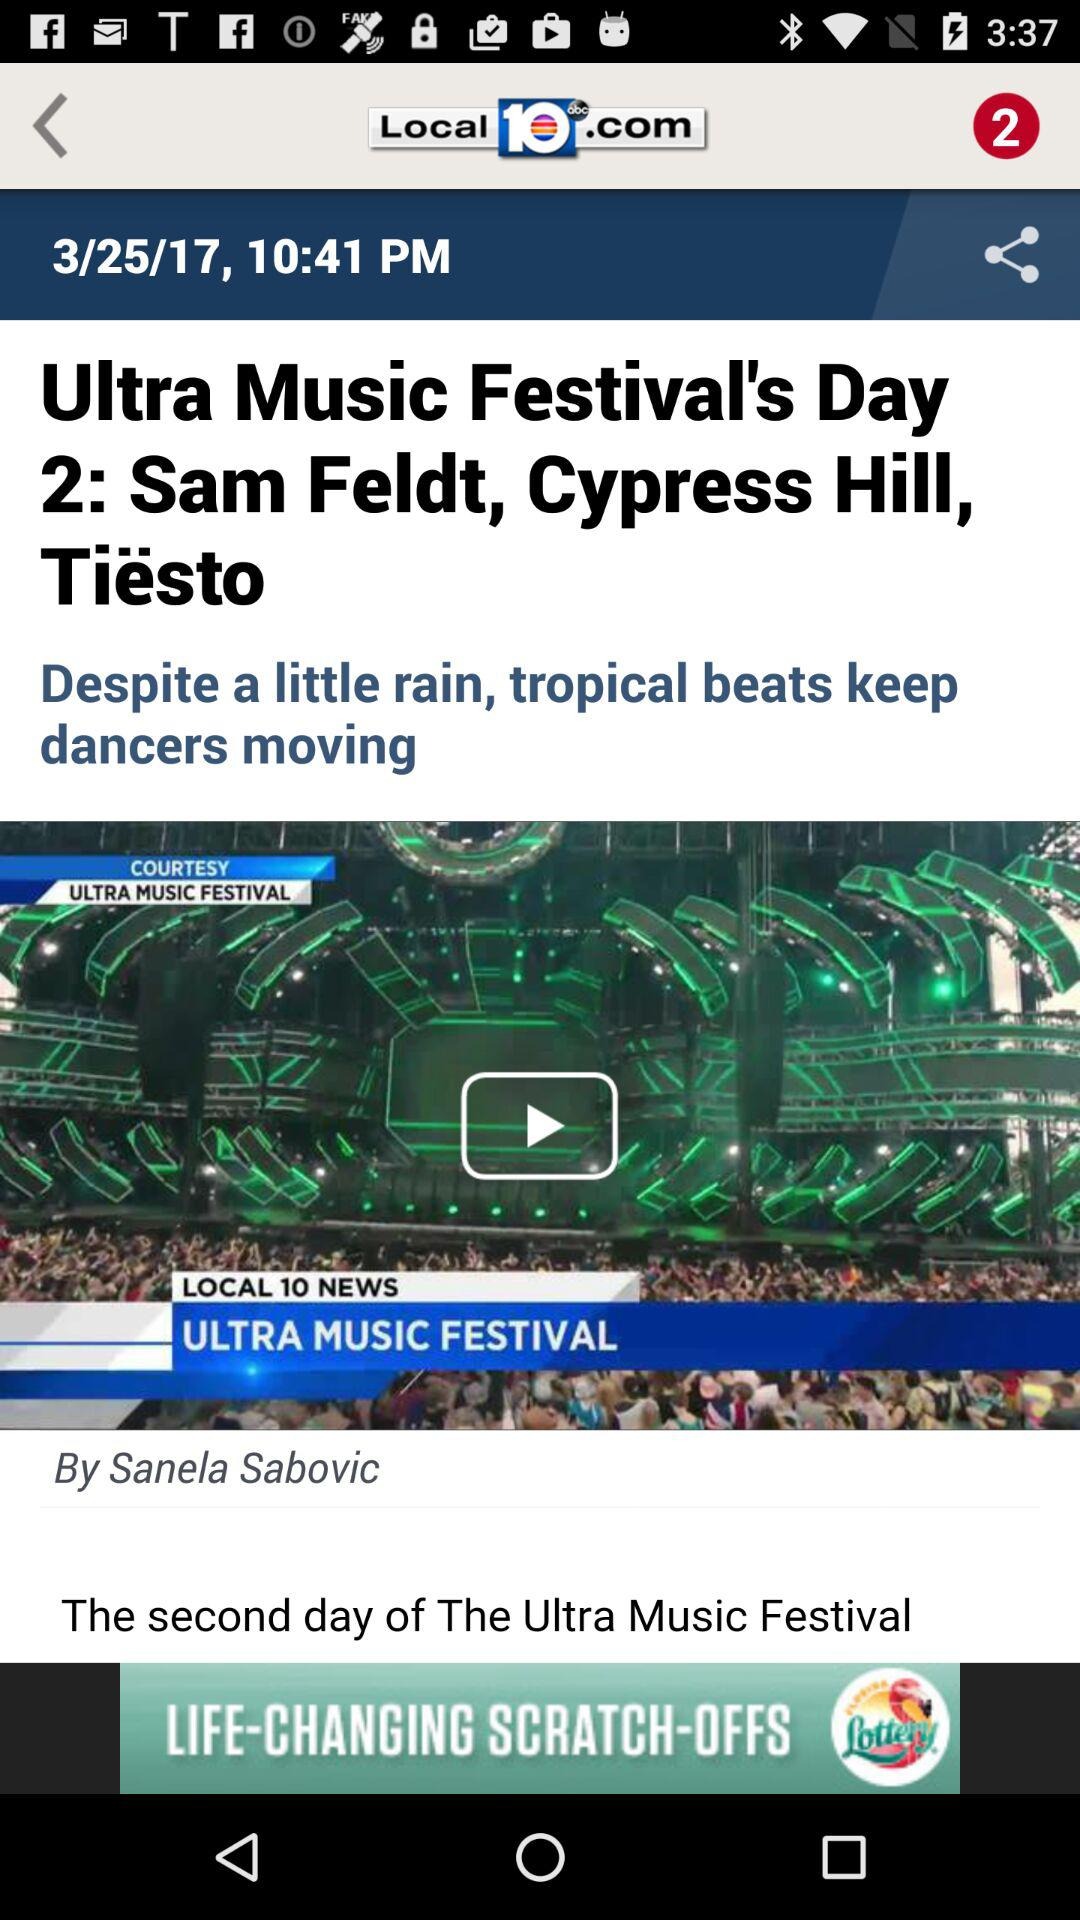When was the "Ultra Music Festival"?
When the provided information is insufficient, respond with <no answer>. <no answer> 